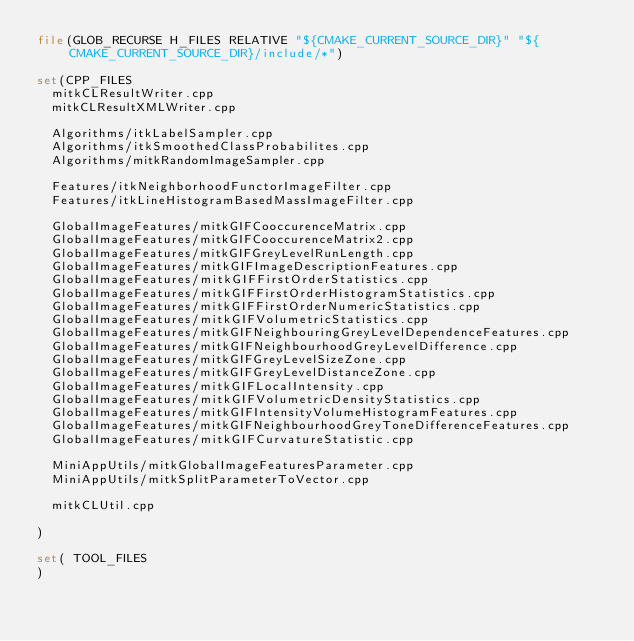Convert code to text. <code><loc_0><loc_0><loc_500><loc_500><_CMake_>file(GLOB_RECURSE H_FILES RELATIVE "${CMAKE_CURRENT_SOURCE_DIR}" "${CMAKE_CURRENT_SOURCE_DIR}/include/*")

set(CPP_FILES
  mitkCLResultWriter.cpp
  mitkCLResultXMLWriter.cpp

  Algorithms/itkLabelSampler.cpp
  Algorithms/itkSmoothedClassProbabilites.cpp
  Algorithms/mitkRandomImageSampler.cpp

  Features/itkNeighborhoodFunctorImageFilter.cpp
  Features/itkLineHistogramBasedMassImageFilter.cpp

  GlobalImageFeatures/mitkGIFCooccurenceMatrix.cpp
  GlobalImageFeatures/mitkGIFCooccurenceMatrix2.cpp
  GlobalImageFeatures/mitkGIFGreyLevelRunLength.cpp
  GlobalImageFeatures/mitkGIFImageDescriptionFeatures.cpp
  GlobalImageFeatures/mitkGIFFirstOrderStatistics.cpp
  GlobalImageFeatures/mitkGIFFirstOrderHistogramStatistics.cpp
  GlobalImageFeatures/mitkGIFFirstOrderNumericStatistics.cpp
  GlobalImageFeatures/mitkGIFVolumetricStatistics.cpp
  GlobalImageFeatures/mitkGIFNeighbouringGreyLevelDependenceFeatures.cpp
  GlobalImageFeatures/mitkGIFNeighbourhoodGreyLevelDifference.cpp
  GlobalImageFeatures/mitkGIFGreyLevelSizeZone.cpp
  GlobalImageFeatures/mitkGIFGreyLevelDistanceZone.cpp
  GlobalImageFeatures/mitkGIFLocalIntensity.cpp
  GlobalImageFeatures/mitkGIFVolumetricDensityStatistics.cpp
  GlobalImageFeatures/mitkGIFIntensityVolumeHistogramFeatures.cpp
  GlobalImageFeatures/mitkGIFNeighbourhoodGreyToneDifferenceFeatures.cpp
  GlobalImageFeatures/mitkGIFCurvatureStatistic.cpp

  MiniAppUtils/mitkGlobalImageFeaturesParameter.cpp
  MiniAppUtils/mitkSplitParameterToVector.cpp

  mitkCLUtil.cpp

)

set( TOOL_FILES
)
</code> 